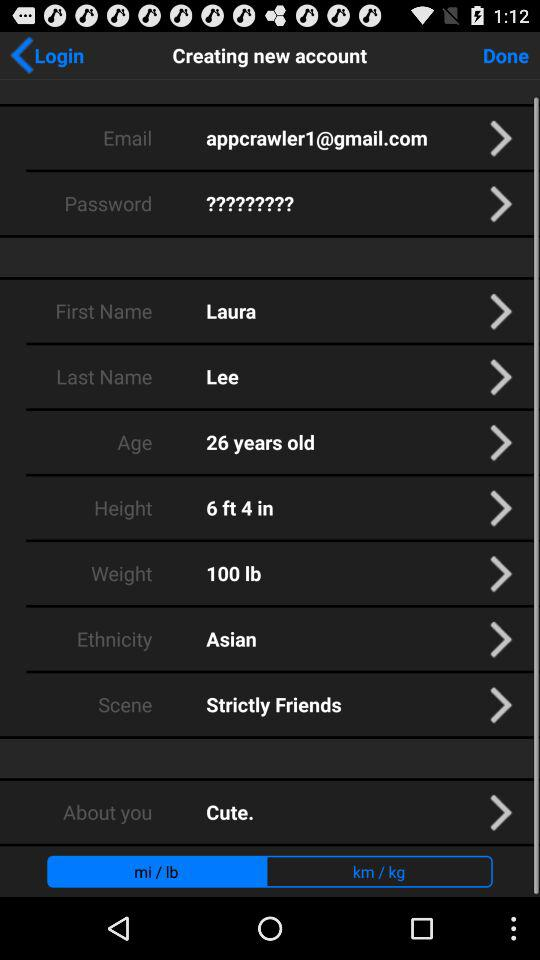What is the "Scene"? The "Scene" is "Strictly Friends". 